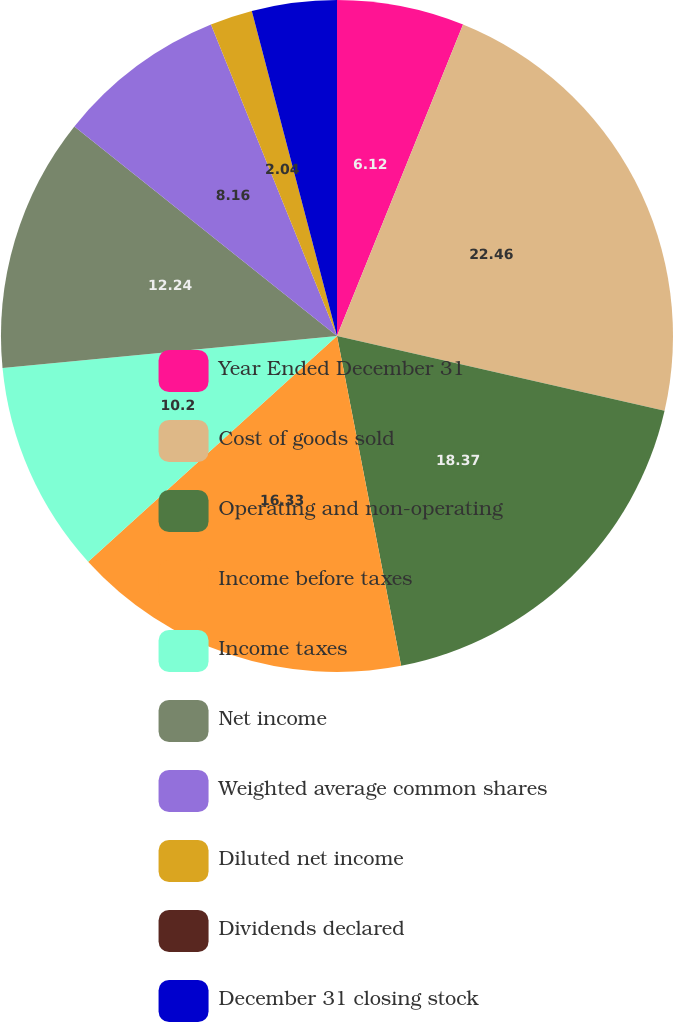<chart> <loc_0><loc_0><loc_500><loc_500><pie_chart><fcel>Year Ended December 31<fcel>Cost of goods sold<fcel>Operating and non-operating<fcel>Income before taxes<fcel>Income taxes<fcel>Net income<fcel>Weighted average common shares<fcel>Diluted net income<fcel>Dividends declared<fcel>December 31 closing stock<nl><fcel>6.12%<fcel>22.45%<fcel>18.37%<fcel>16.33%<fcel>10.2%<fcel>12.24%<fcel>8.16%<fcel>2.04%<fcel>0.0%<fcel>4.08%<nl></chart> 